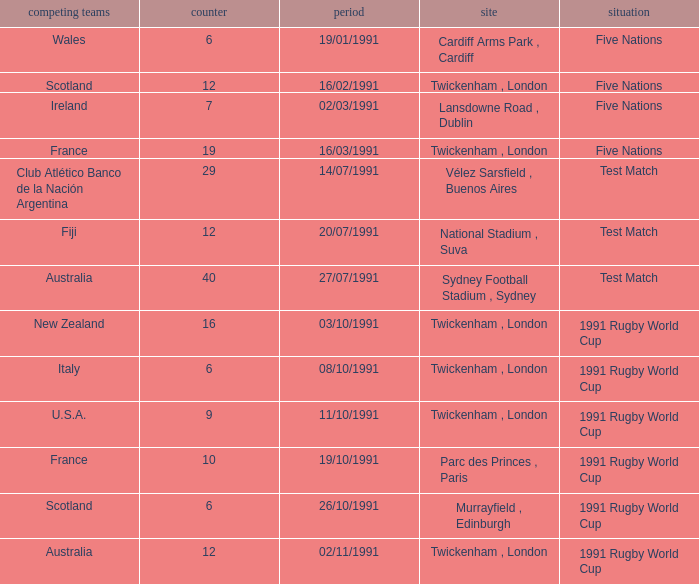What is Opposing Teams, when Date is "11/10/1991"? U.S.A. 